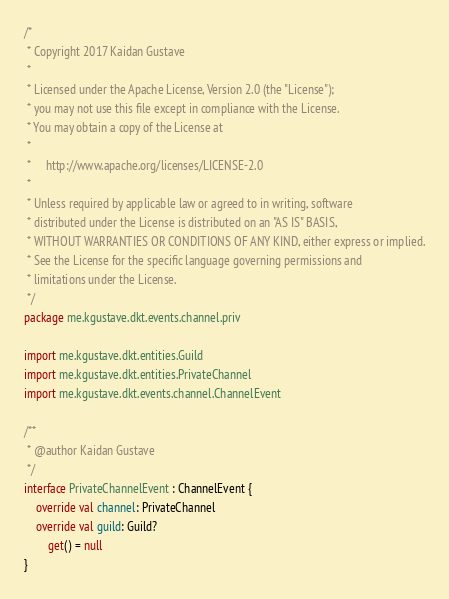<code> <loc_0><loc_0><loc_500><loc_500><_Kotlin_>/*
 * Copyright 2017 Kaidan Gustave
 *
 * Licensed under the Apache License, Version 2.0 (the "License");
 * you may not use this file except in compliance with the License.
 * You may obtain a copy of the License at
 *
 *     http://www.apache.org/licenses/LICENSE-2.0
 *
 * Unless required by applicable law or agreed to in writing, software
 * distributed under the License is distributed on an "AS IS" BASIS,
 * WITHOUT WARRANTIES OR CONDITIONS OF ANY KIND, either express or implied.
 * See the License for the specific language governing permissions and
 * limitations under the License.
 */
package me.kgustave.dkt.events.channel.priv

import me.kgustave.dkt.entities.Guild
import me.kgustave.dkt.entities.PrivateChannel
import me.kgustave.dkt.events.channel.ChannelEvent

/**
 * @author Kaidan Gustave
 */
interface PrivateChannelEvent : ChannelEvent {
    override val channel: PrivateChannel
    override val guild: Guild?
        get() = null
}
</code> 